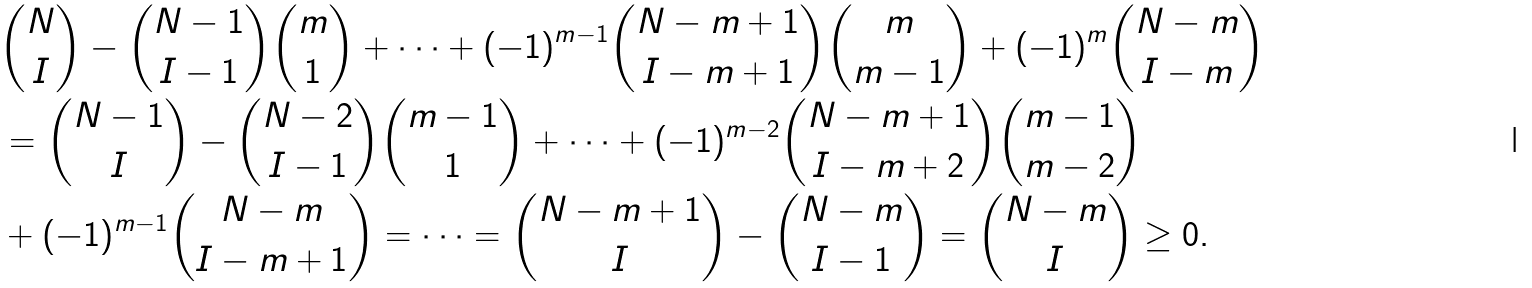<formula> <loc_0><loc_0><loc_500><loc_500>& \binom { N } { I } - \binom { N - 1 } { I - 1 } \binom { m } { 1 } + \dots + ( - 1 ) ^ { m - 1 } \binom { N - m + 1 } { I - m + 1 } \binom { m } { m - 1 } + ( - 1 ) ^ { m } \binom { N - m } { I - m } \\ & = \binom { N - 1 } { I } - \binom { N - 2 } { I - 1 } \binom { m - 1 } { 1 } + \dots + ( - 1 ) ^ { m - 2 } \binom { N - m + 1 } { I - m + 2 } \binom { m - 1 } { m - 2 } \\ & + ( - 1 ) ^ { m - 1 } \binom { N - m } { I - m + 1 } = \dots = \binom { N - m + 1 } { I } - \binom { N - m } { I - 1 } = \binom { N - m } { I } \geq 0 .</formula> 